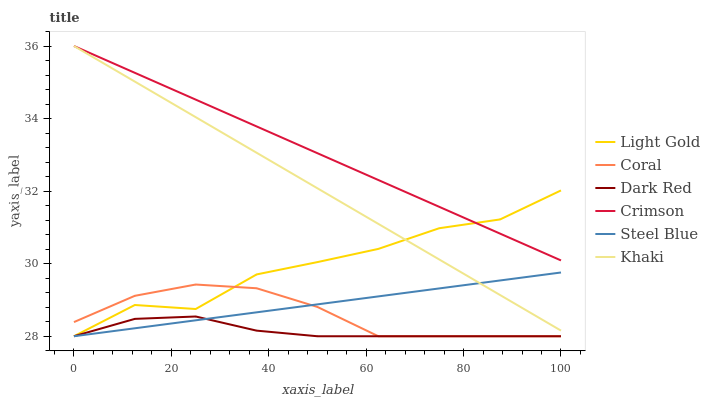Does Dark Red have the minimum area under the curve?
Answer yes or no. Yes. Does Crimson have the maximum area under the curve?
Answer yes or no. Yes. Does Coral have the minimum area under the curve?
Answer yes or no. No. Does Coral have the maximum area under the curve?
Answer yes or no. No. Is Crimson the smoothest?
Answer yes or no. Yes. Is Light Gold the roughest?
Answer yes or no. Yes. Is Dark Red the smoothest?
Answer yes or no. No. Is Dark Red the roughest?
Answer yes or no. No. Does Dark Red have the lowest value?
Answer yes or no. Yes. Does Crimson have the lowest value?
Answer yes or no. No. Does Crimson have the highest value?
Answer yes or no. Yes. Does Coral have the highest value?
Answer yes or no. No. Is Steel Blue less than Crimson?
Answer yes or no. Yes. Is Crimson greater than Dark Red?
Answer yes or no. Yes. Does Coral intersect Steel Blue?
Answer yes or no. Yes. Is Coral less than Steel Blue?
Answer yes or no. No. Is Coral greater than Steel Blue?
Answer yes or no. No. Does Steel Blue intersect Crimson?
Answer yes or no. No. 